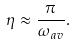Convert formula to latex. <formula><loc_0><loc_0><loc_500><loc_500>\eta \approx \frac { \pi } { \omega _ { a v } } .</formula> 